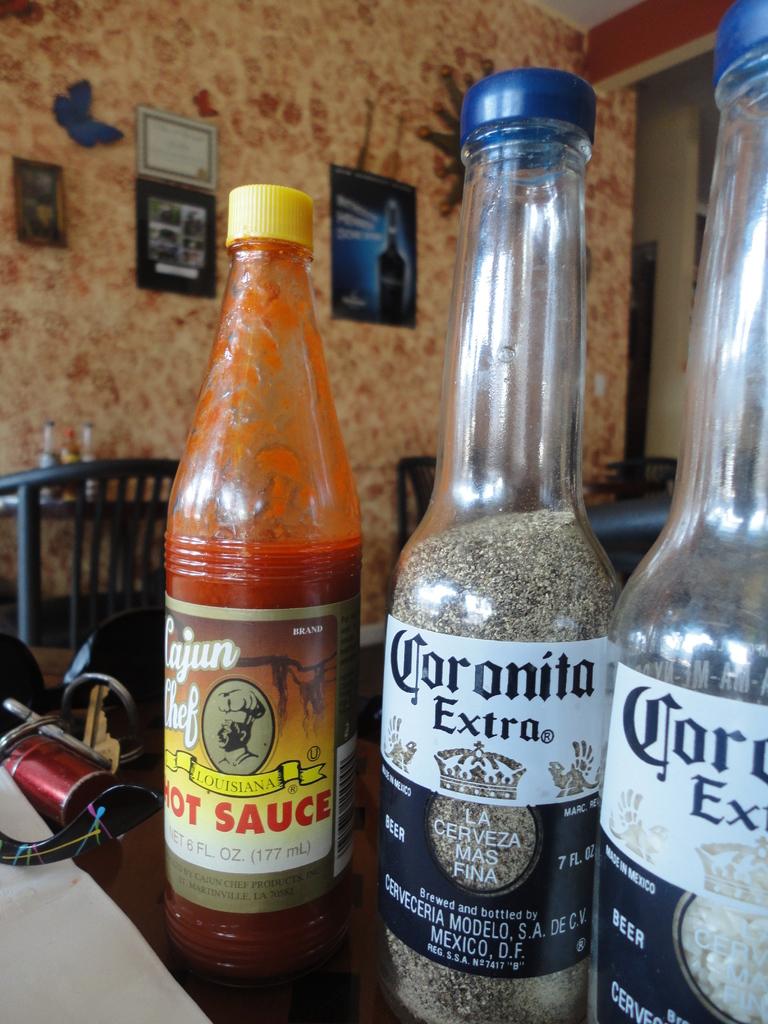What's the name of this sauce?
Offer a terse response. Cajun chef. What beer brand is on the labels on the right?
Offer a very short reply. Corona. 